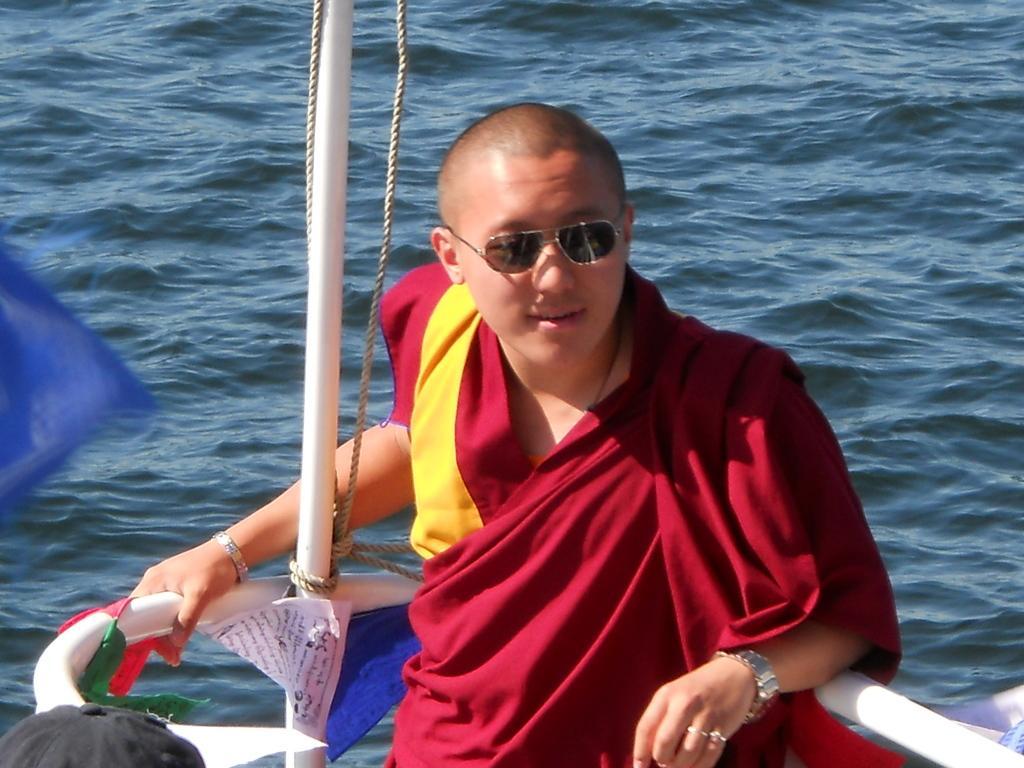Describe this image in one or two sentences. In the image we can see a man wearing clothes, wrist watch, goggles and a finger ring. This is a rope and water. This is a pole and a cap. 